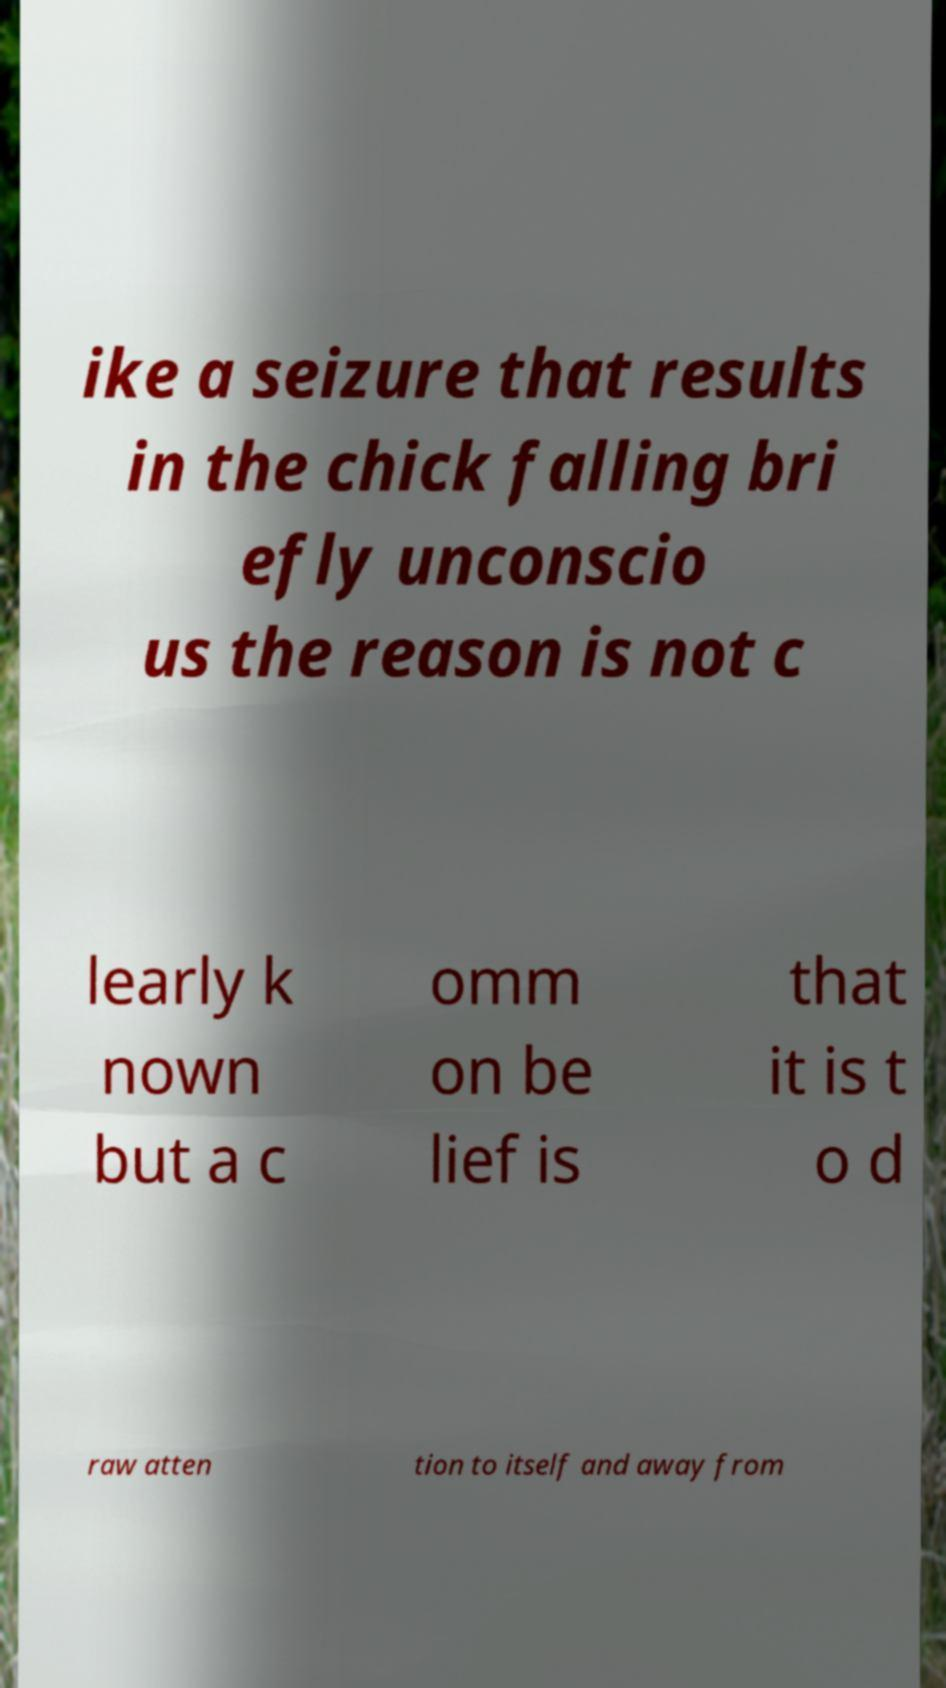Please identify and transcribe the text found in this image. ike a seizure that results in the chick falling bri efly unconscio us the reason is not c learly k nown but a c omm on be lief is that it is t o d raw atten tion to itself and away from 